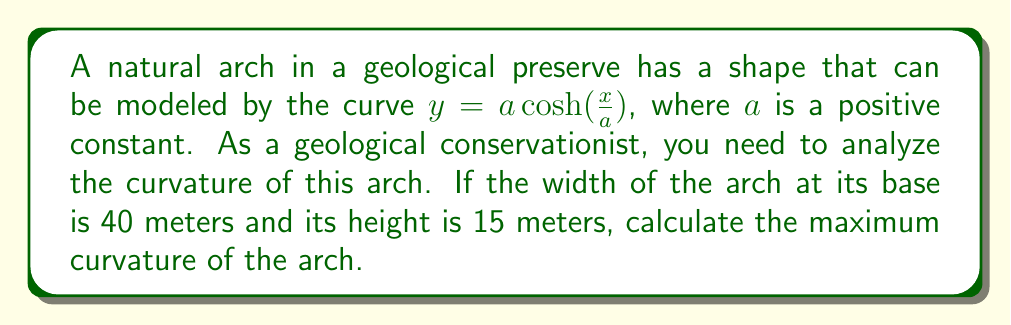Could you help me with this problem? To solve this problem, we'll follow these steps:

1) First, we need to find the value of $a$. We can use the given dimensions of the arch:
   - Width at base = 40 meters, so $x$ ranges from -20 to 20
   - Height = 15 meters

   At $x = 20$, $y = 15$. So:
   
   $15 = a \cosh(\frac{20}{a})$

2) We can solve this equation numerically to find $a \approx 13.3$ meters.

3) Now that we have $a$, we can calculate the curvature. The formula for curvature $\kappa$ of a function $y(x)$ is:

   $$\kappa = \frac{|y''|}{(1 + (y')^2)^{3/2}}$$

4) For $y = a \cosh(\frac{x}{a})$, we have:
   
   $y' = \sinh(\frac{x}{a})$
   
   $y'' = \frac{1}{a}\cosh(\frac{x}{a})$

5) Substituting these into the curvature formula:

   $$\kappa = \frac{|\frac{1}{a}\cosh(\frac{x}{a})|}{(1 + \sinh^2(\frac{x}{a}))^{3/2}}$$

6) Simplifying using the identity $\cosh^2(t) - \sinh^2(t) = 1$:

   $$\kappa = \frac{1}{a}\frac{1}{\cosh^2(\frac{x}{a})}$$

7) The maximum curvature occurs at the top of the arch where $x = 0$:

   $$\kappa_{max} = \frac{1}{a}\frac{1}{\cosh^2(0)} = \frac{1}{a}$$

8) Substituting $a \approx 13.3$:

   $$\kappa_{max} \approx \frac{1}{13.3} \approx 0.0752 \text{ m}^{-1}$$
Answer: The maximum curvature of the arch is approximately $0.0752 \text{ m}^{-1}$. 